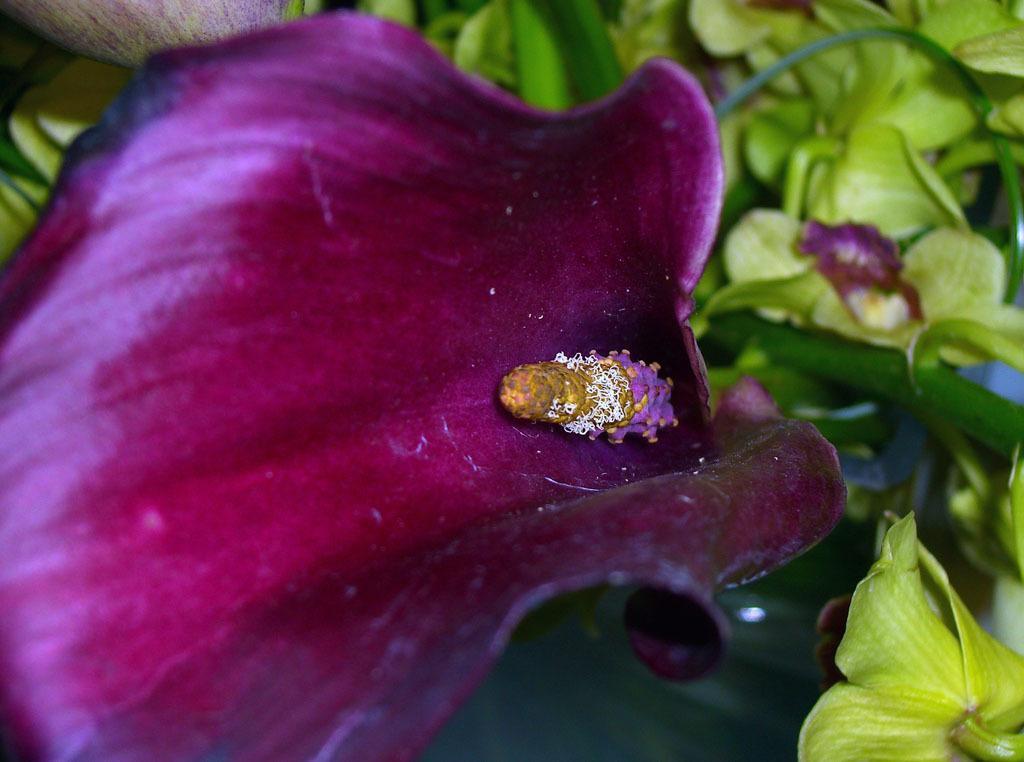In one or two sentences, can you explain what this image depicts? In this image we can see the flowers, leaves and also the stems. 